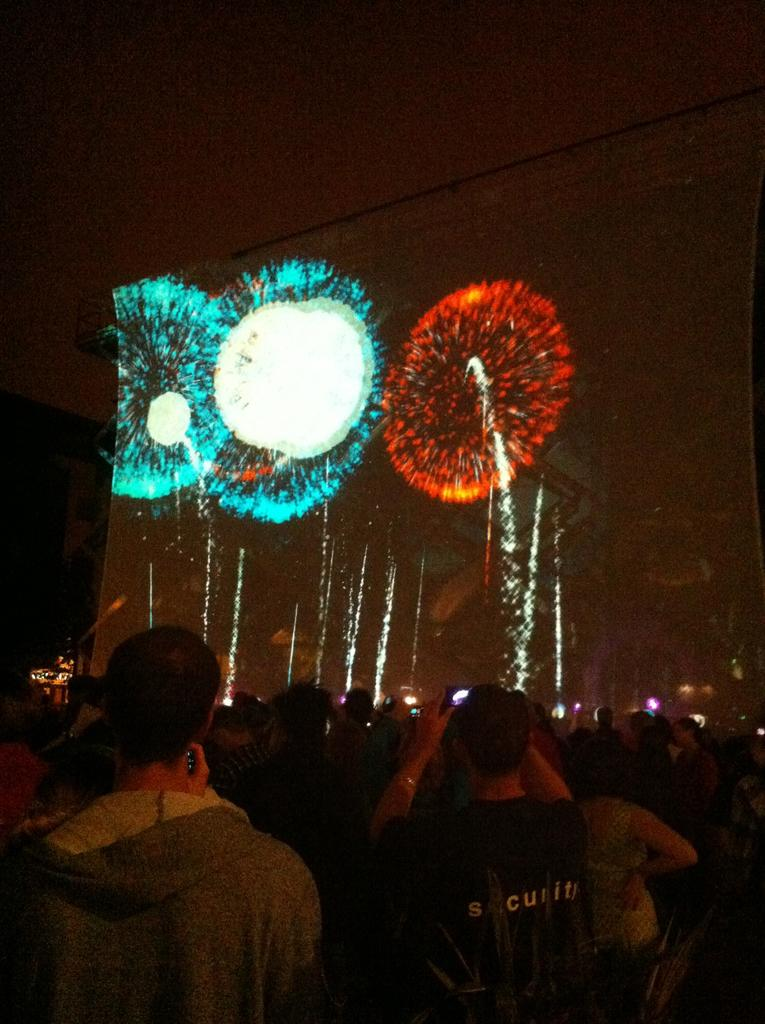Who or what can be seen in the image? There are people in the image. What additional detail can be observed in the background of the image? There are sparkles visible in the background of the image. What type of garden can be seen in the image? There is no garden present in the image; it only features people and sparkles in the background. 